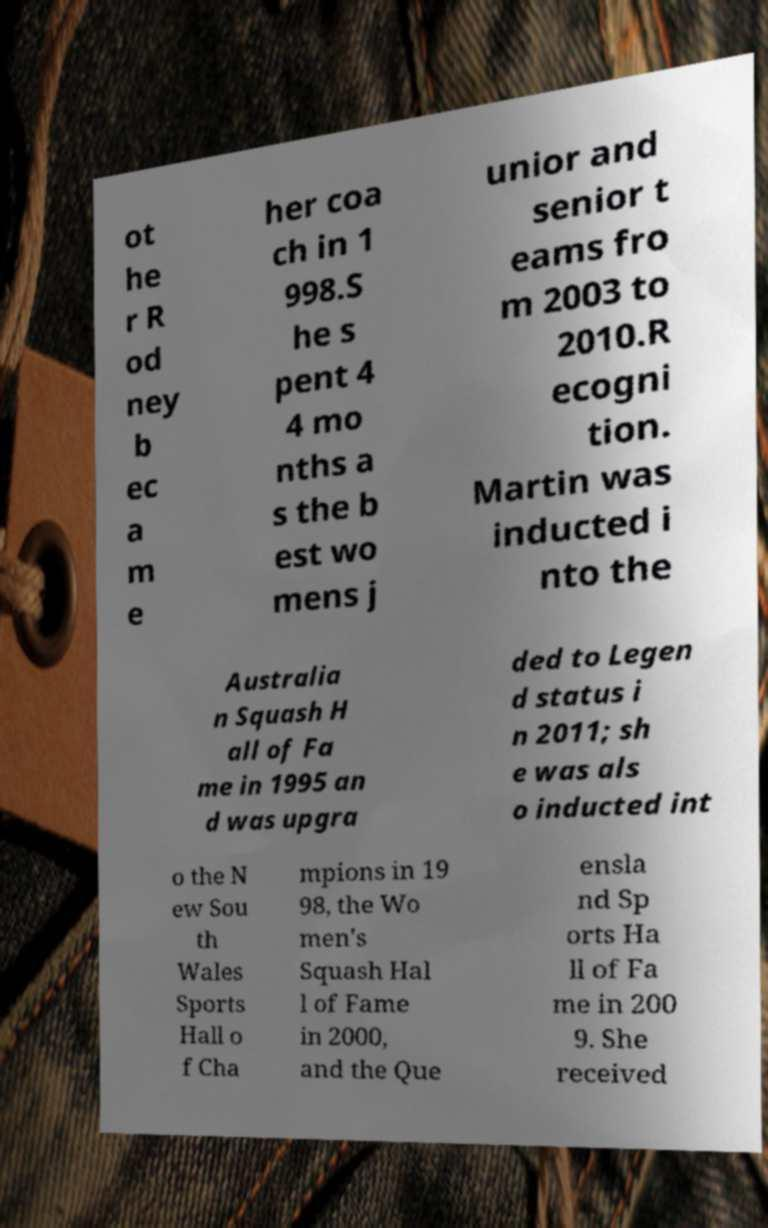Could you extract and type out the text from this image? ot he r R od ney b ec a m e her coa ch in 1 998.S he s pent 4 4 mo nths a s the b est wo mens j unior and senior t eams fro m 2003 to 2010.R ecogni tion. Martin was inducted i nto the Australia n Squash H all of Fa me in 1995 an d was upgra ded to Legen d status i n 2011; sh e was als o inducted int o the N ew Sou th Wales Sports Hall o f Cha mpions in 19 98, the Wo men's Squash Hal l of Fame in 2000, and the Que ensla nd Sp orts Ha ll of Fa me in 200 9. She received 